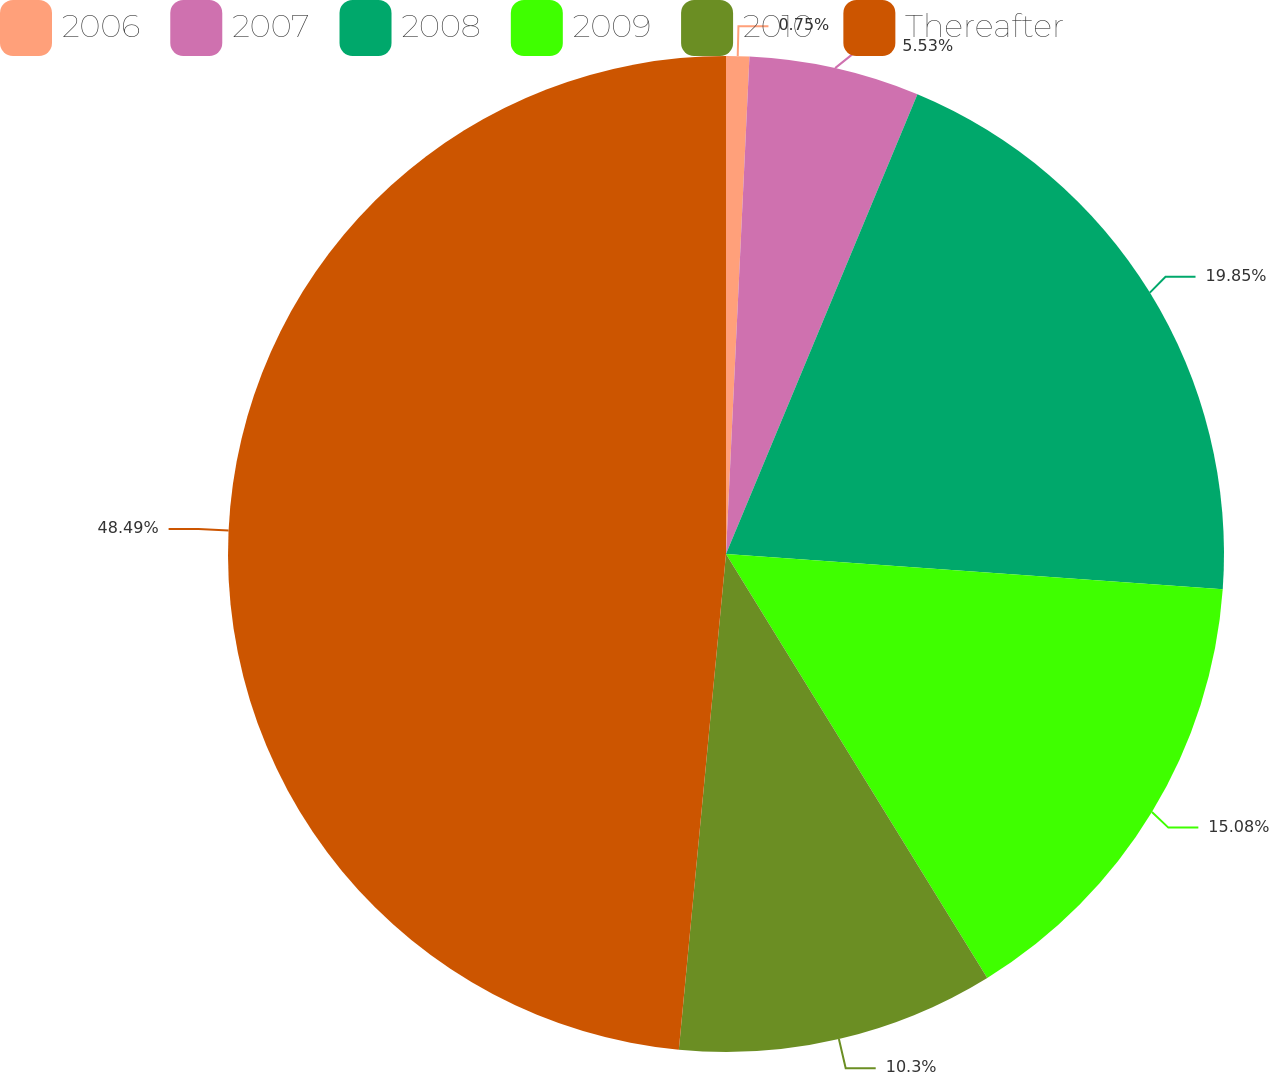Convert chart to OTSL. <chart><loc_0><loc_0><loc_500><loc_500><pie_chart><fcel>2006<fcel>2007<fcel>2008<fcel>2009<fcel>2010<fcel>Thereafter<nl><fcel>0.75%<fcel>5.53%<fcel>19.85%<fcel>15.08%<fcel>10.3%<fcel>48.49%<nl></chart> 